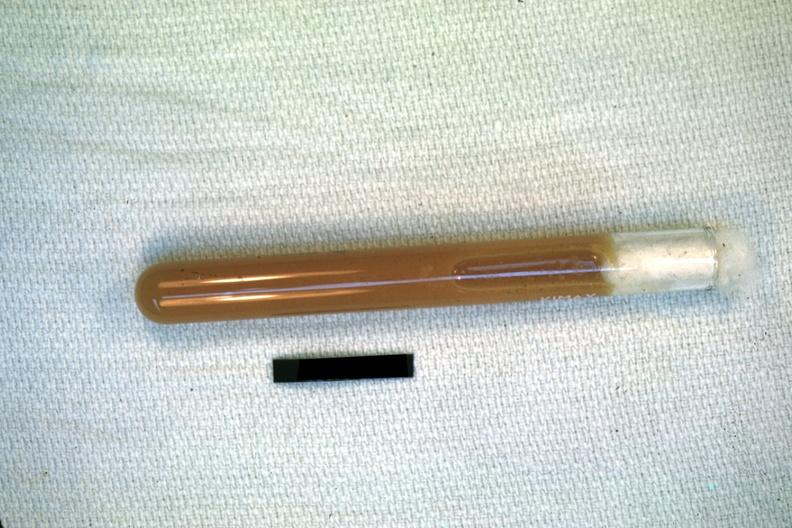what illustrates pus from the peritoneal cavity?
Answer the question using a single word or phrase. Case of peritonitis slide 